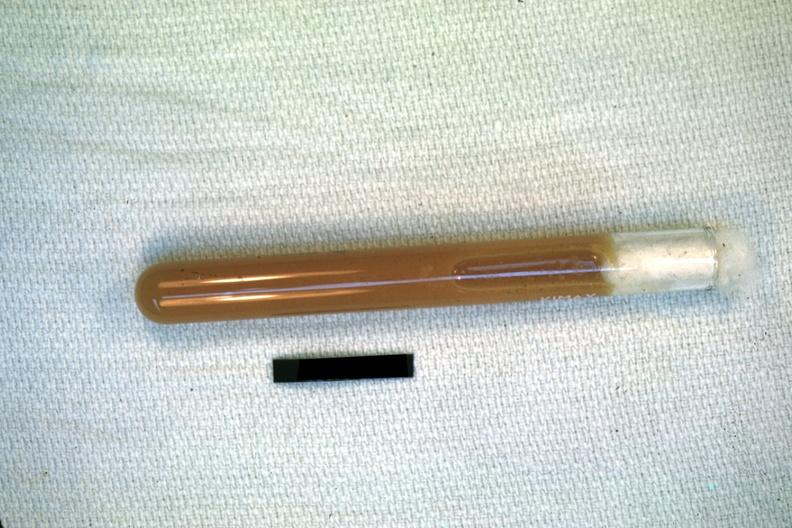what illustrates pus from the peritoneal cavity?
Answer the question using a single word or phrase. Case of peritonitis slide 